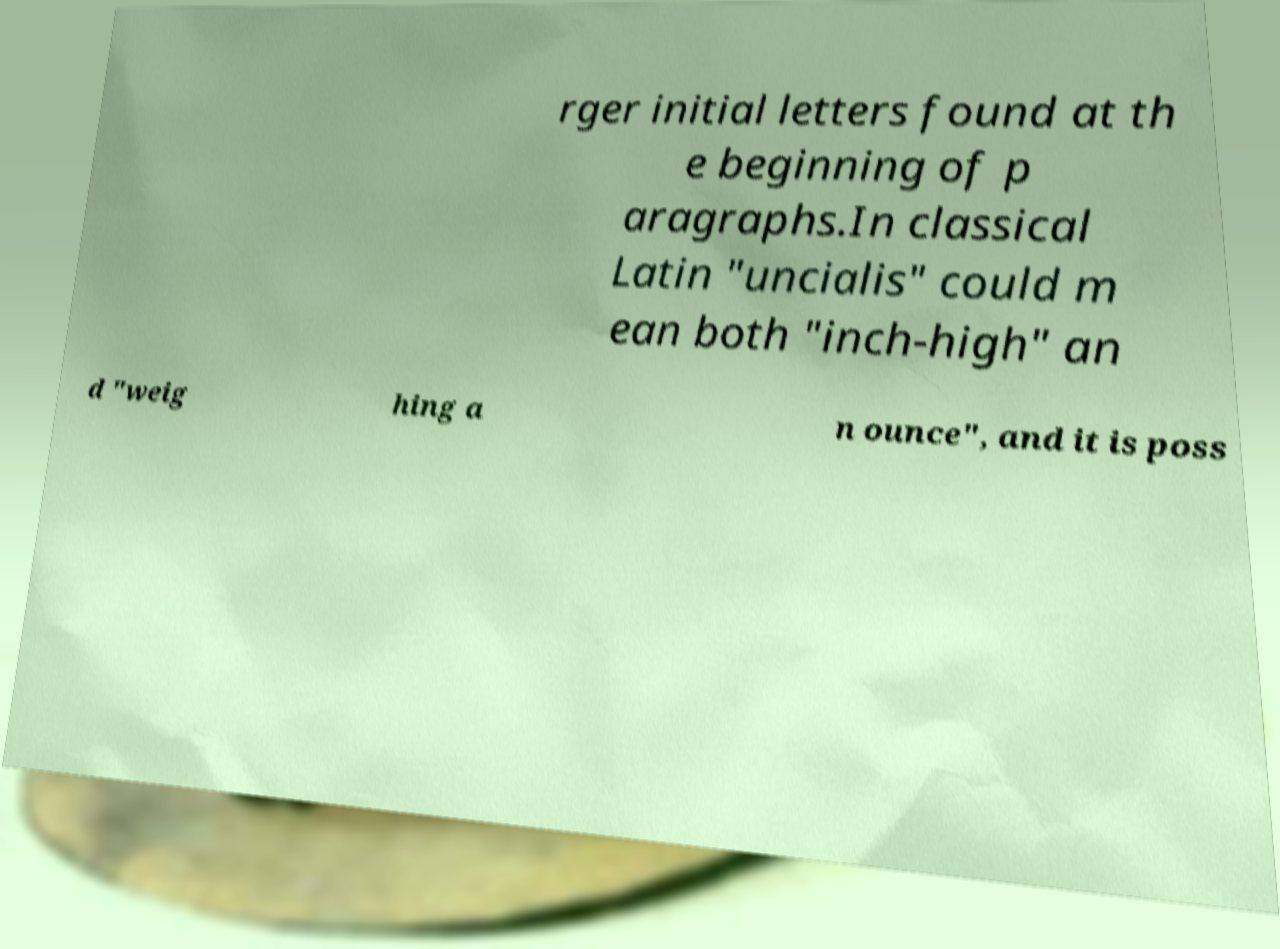For documentation purposes, I need the text within this image transcribed. Could you provide that? rger initial letters found at th e beginning of p aragraphs.In classical Latin "uncialis" could m ean both "inch-high" an d "weig hing a n ounce", and it is poss 